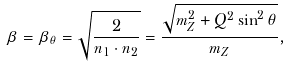<formula> <loc_0><loc_0><loc_500><loc_500>\beta = \beta _ { \theta } = \sqrt { \frac { 2 } { n _ { 1 } \cdot n _ { 2 } } } = \frac { \sqrt { m _ { Z } ^ { 2 } + Q ^ { 2 } \sin ^ { 2 } \theta } } { m _ { Z } } ,</formula> 